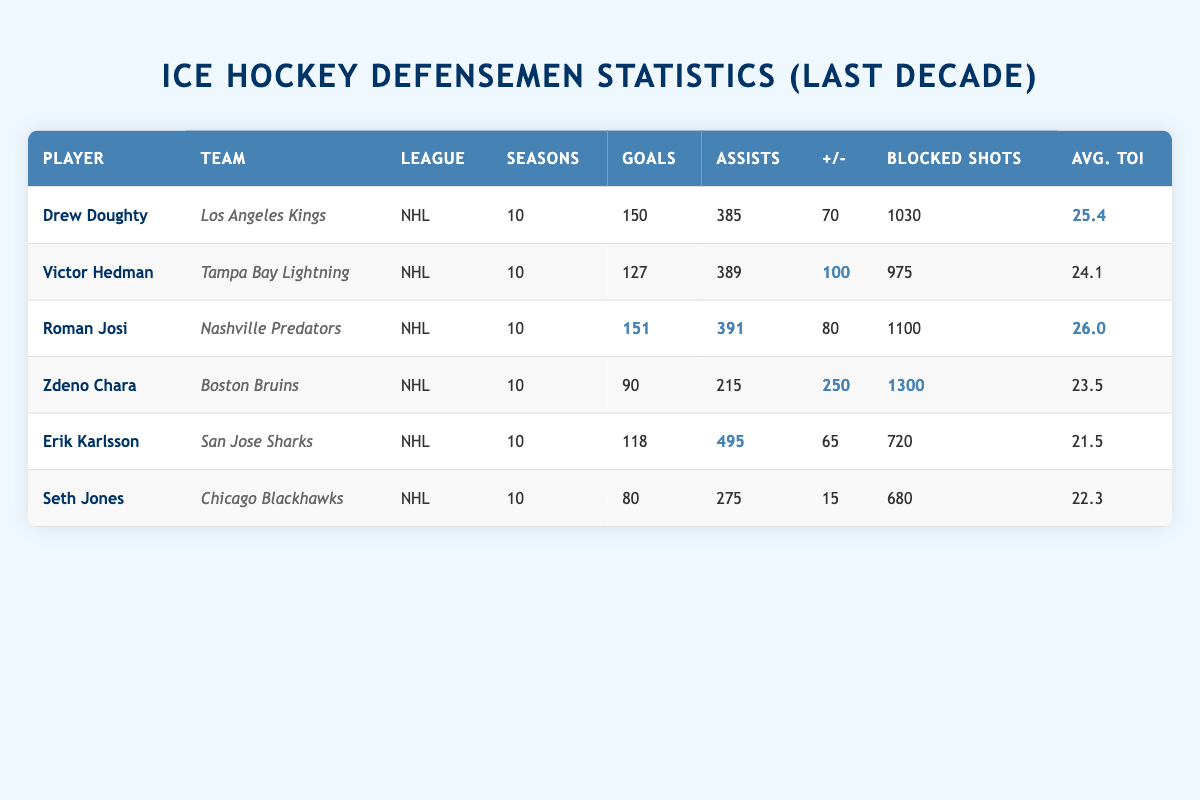What is the total number of goals scored by all defensemen listed? To find the total number of goals, we sum the goals scored by each player: 150 (Doughty) + 127 (Hedman) + 151 (Josi) + 90 (Chara) + 118 (Karlsson) + 80 (Jones) = 716.
Answer: 716 Which player has the highest plus/minus rating? By inspecting the plus/minus column, we can see that Zdeno Chara has the highest plus/minus rating of 250, compared to the others.
Answer: 250 What is the average time on ice for all defensemen? To calculate the average, we sum the average time on ice values: 25.4 (Doughty) + 24.1 (Hedman) + 26.0 (Josi) + 23.5 (Chara) + 21.5 (Karlsson) + 22.3 (Jones) = 142.8, then divide by the number of players (6): 142.8 / 6 ≈ 23.8.
Answer: 23.8 Did any player score more than 150 goals? In the goals column, we look for any player with a goal count exceeding 150. Only Roman Josi scored exactly 151 goals.
Answer: Yes How many blocked shots did Roman Josi have compared to Drew Doughty? Looking at the blocked shots column, Roman Josi had 1100 blocked shots and Drew Doughty had 1030. The difference is 1100 - 1030 = 70 more blocked shots for Josi.
Answer: 70 more for Josi Which defenseman played the most average time on ice? By checking the average time on ice, Roman Josi has the highest value at 26.0, compared to others whose times are lower.
Answer: 26.0 Is Victor Hedman's assist total higher than Erik Karlsson's? Comparing the assist totals, Victor Hedman has 389 assists while Erik Karlsson has 495 assists. Therefore, Hedman's total is not higher than Karlsson's.
Answer: No Who has the lowest goals scored among the listed defensemen? The goals scored column shows that Seth Jones has the lowest with just 80 goals.
Answer: 80 